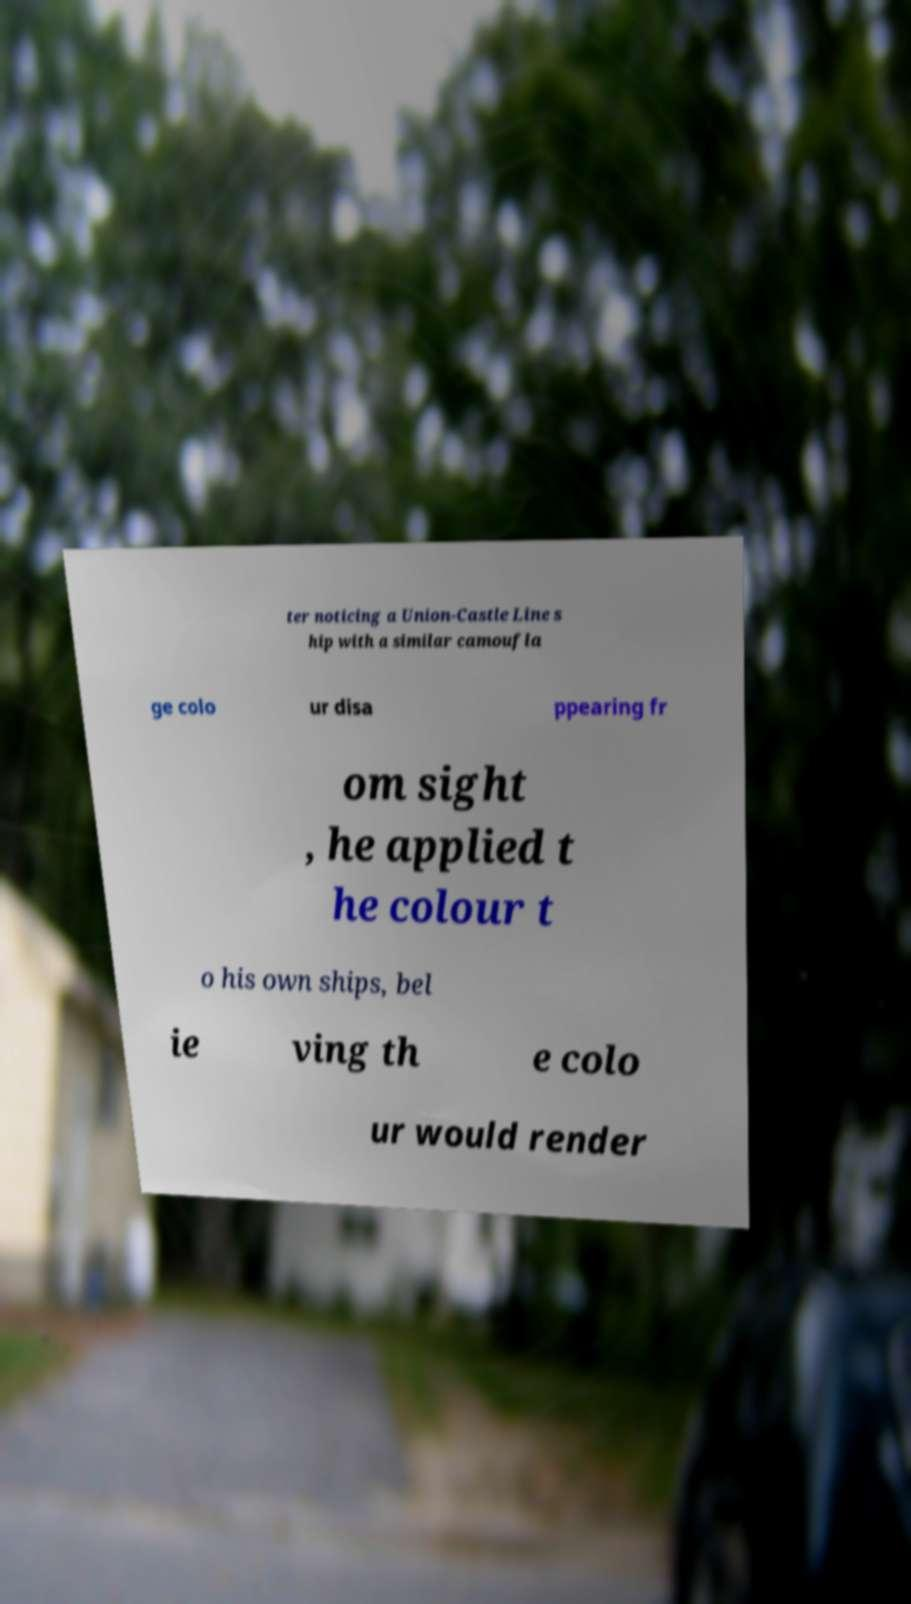There's text embedded in this image that I need extracted. Can you transcribe it verbatim? ter noticing a Union-Castle Line s hip with a similar camoufla ge colo ur disa ppearing fr om sight , he applied t he colour t o his own ships, bel ie ving th e colo ur would render 